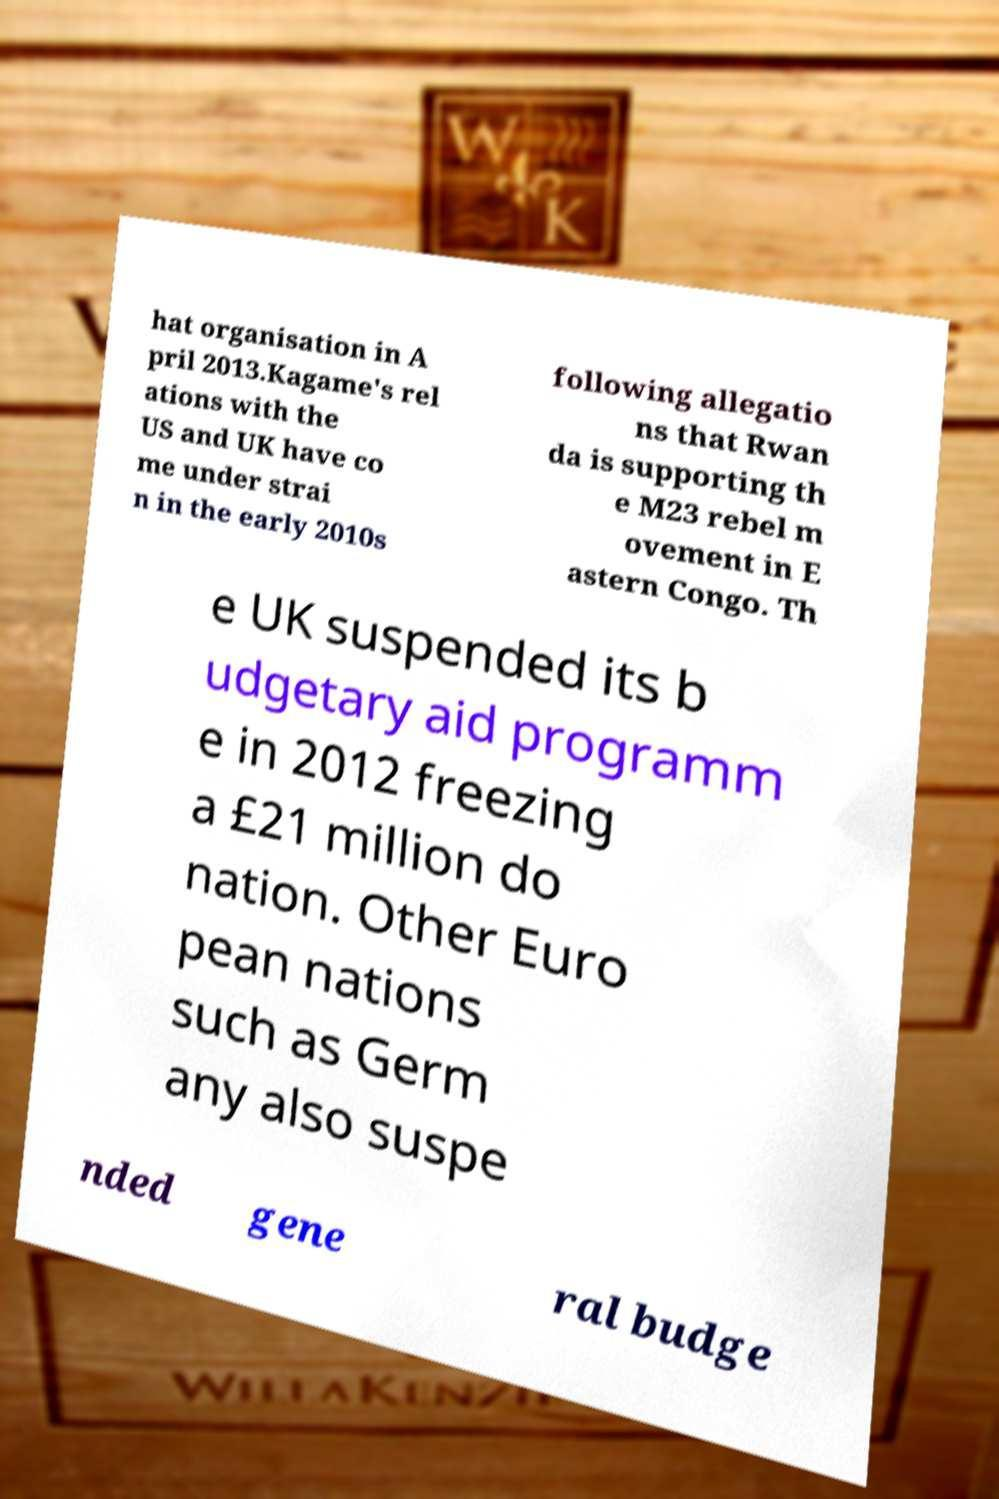Can you read and provide the text displayed in the image?This photo seems to have some interesting text. Can you extract and type it out for me? hat organisation in A pril 2013.Kagame's rel ations with the US and UK have co me under strai n in the early 2010s following allegatio ns that Rwan da is supporting th e M23 rebel m ovement in E astern Congo. Th e UK suspended its b udgetary aid programm e in 2012 freezing a £21 million do nation. Other Euro pean nations such as Germ any also suspe nded gene ral budge 